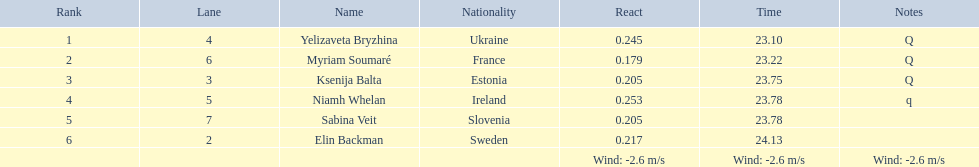What are the complete list of names? Yelizaveta Bryzhina, Myriam Soumaré, Ksenija Balta, Niamh Whelan, Sabina Veit, Elin Backman. What are their respective completion times? 23.10, 23.22, 23.75, 23.78, 23.78, 24.13. Could you help me parse every detail presented in this table? {'header': ['Rank', 'Lane', 'Name', 'Nationality', 'React', 'Time', 'Notes'], 'rows': [['1', '4', 'Yelizaveta Bryzhina', 'Ukraine', '0.245', '23.10', 'Q'], ['2', '6', 'Myriam Soumaré', 'France', '0.179', '23.22', 'Q'], ['3', '3', 'Ksenija Balta', 'Estonia', '0.205', '23.75', 'Q'], ['4', '5', 'Niamh Whelan', 'Ireland', '0.253', '23.78', 'q'], ['5', '7', 'Sabina Veit', 'Slovenia', '0.205', '23.78', ''], ['6', '2', 'Elin Backman', 'Sweden', '0.217', '24.13', ''], ['', '', '', '', 'Wind: -2.6\xa0m/s', 'Wind: -2.6\xa0m/s', 'Wind: -2.6\xa0m/s']]} And, what was the finishing time for ellen backman? 24.13. 